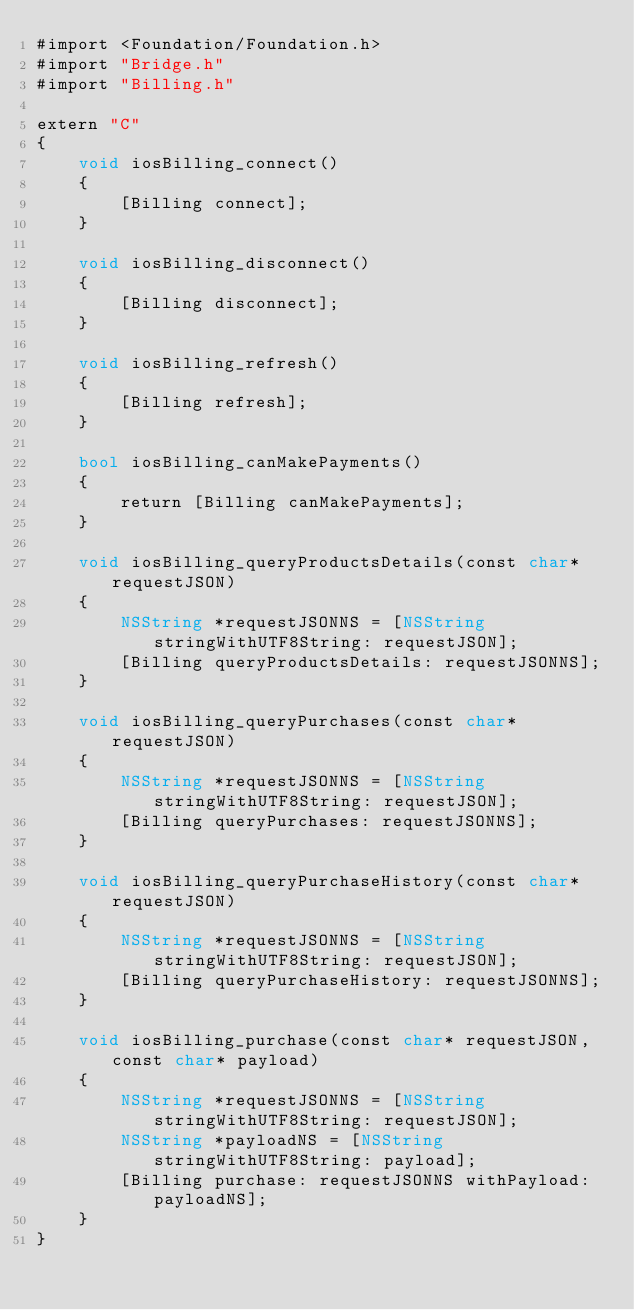Convert code to text. <code><loc_0><loc_0><loc_500><loc_500><_ObjectiveC_>#import <Foundation/Foundation.h>
#import "Bridge.h"
#import "Billing.h"

extern "C"
{
	void iosBilling_connect()
	{
		[Billing connect];
	}
	
	void iosBilling_disconnect()
	{
		[Billing disconnect];
	}
	
	void iosBilling_refresh()
	{
		[Billing refresh];
	}
	
	bool iosBilling_canMakePayments()
	{
		return [Billing canMakePayments];
	}
	
	void iosBilling_queryProductsDetails(const char* requestJSON)
	{
		NSString *requestJSONNS = [NSString stringWithUTF8String: requestJSON];
		[Billing queryProductsDetails: requestJSONNS];
	}
	
	void iosBilling_queryPurchases(const char* requestJSON)
	{
		NSString *requestJSONNS = [NSString stringWithUTF8String: requestJSON];
		[Billing queryPurchases: requestJSONNS];
	}
	
	void iosBilling_queryPurchaseHistory(const char* requestJSON)
	{
		NSString *requestJSONNS = [NSString stringWithUTF8String: requestJSON];
		[Billing queryPurchaseHistory: requestJSONNS];
	}
	
	void iosBilling_purchase(const char* requestJSON, const char* payload)
	{
		NSString *requestJSONNS = [NSString stringWithUTF8String: requestJSON];
		NSString *payloadNS = [NSString stringWithUTF8String: payload];
		[Billing purchase: requestJSONNS withPayload: payloadNS];
	}
}

</code> 